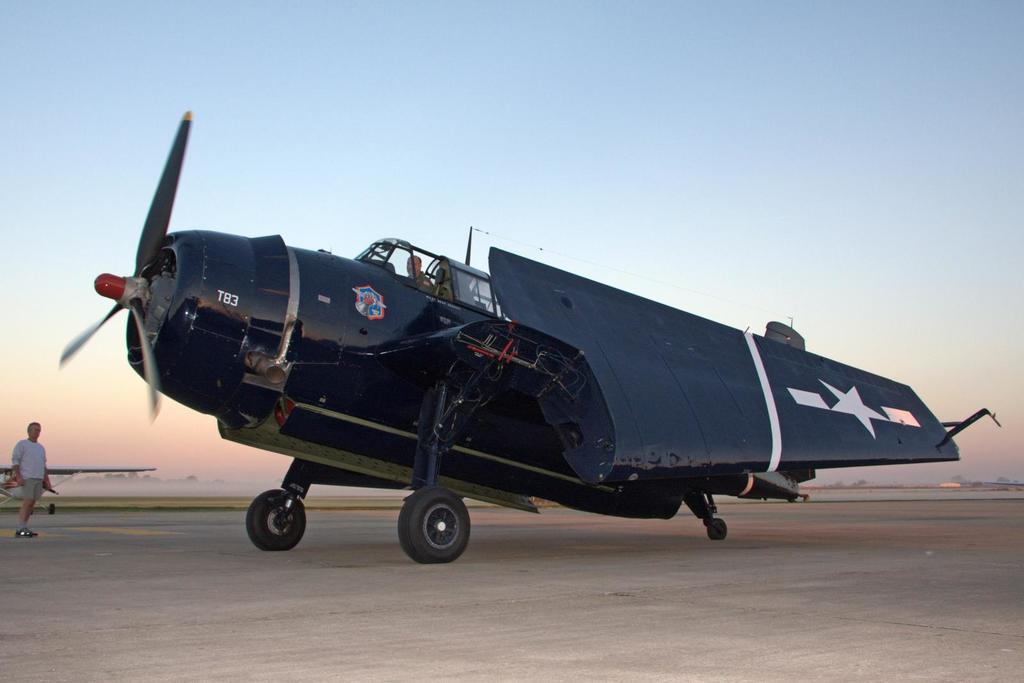<image>
Give a short and clear explanation of the subsequent image. An aircraft numbered T83 sitting on the runway. 